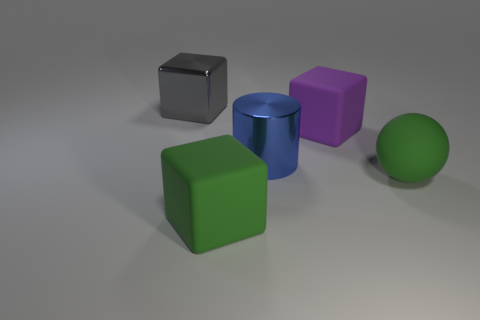What color is the big object on the right side of the purple rubber cube behind the big blue thing?
Offer a very short reply. Green. Is the size of the purple rubber object the same as the green sphere?
Provide a short and direct response. Yes. Is the large green thing left of the sphere made of the same material as the cube on the right side of the blue metallic thing?
Offer a terse response. Yes. What is the shape of the big object that is behind the rubber block that is to the right of the large green thing that is left of the big green sphere?
Your response must be concise. Cube. Are there more large green rubber things than things?
Your answer should be compact. No. Are there any green rubber cubes?
Your answer should be very brief. Yes. What number of things are matte things that are on the left side of the big green sphere or big metallic cylinders that are in front of the large metallic cube?
Your response must be concise. 3. Does the rubber ball have the same color as the large cylinder?
Your response must be concise. No. Are there fewer purple things than green rubber cylinders?
Your answer should be very brief. No. Are there any blue objects left of the blue metallic thing?
Ensure brevity in your answer.  No. 